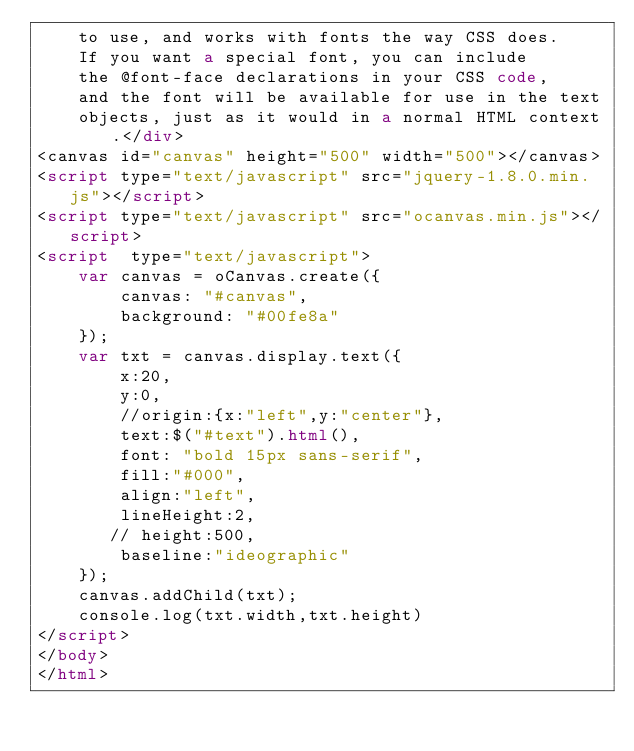<code> <loc_0><loc_0><loc_500><loc_500><_HTML_>    to use, and works with fonts the way CSS does.
    If you want a special font, you can include
    the @font-face declarations in your CSS code,
    and the font will be available for use in the text
    objects, just as it would in a normal HTML context.</div>
<canvas id="canvas" height="500" width="500"></canvas>
<script type="text/javascript" src="jquery-1.8.0.min.js"></script>
<script type="text/javascript" src="ocanvas.min.js"></script>
<script  type="text/javascript">
    var canvas = oCanvas.create({
        canvas: "#canvas",
        background: "#00fe8a"
    });
    var txt = canvas.display.text({
        x:20,
        y:0,
        //origin:{x:"left",y:"center"},
        text:$("#text").html(),
        font: "bold 15px sans-serif",
        fill:"#000",
        align:"left",
        lineHeight:2,
       // height:500,
        baseline:"ideographic"
    });
    canvas.addChild(txt);
    console.log(txt.width,txt.height)
</script>
</body>
</html></code> 